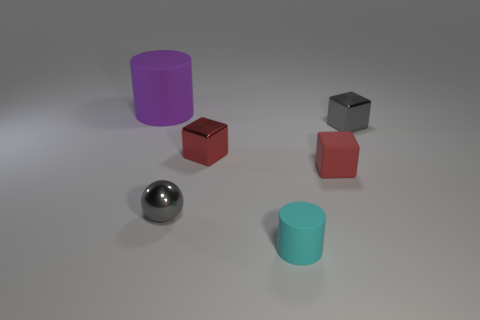Are the cyan cylinder and the tiny red thing that is to the left of the cyan thing made of the same material?
Make the answer very short. No. Do the cylinder that is left of the tiny gray shiny ball and the gray thing on the right side of the small sphere have the same material?
Your response must be concise. No. There is a gray thing that is the same shape as the red matte object; what is its size?
Your response must be concise. Small. How many small shiny cubes have the same color as the metal sphere?
Keep it short and to the point. 1. Are the purple cylinder and the small gray ball made of the same material?
Your response must be concise. No. What number of large purple objects are the same material as the cyan object?
Offer a very short reply. 1. There is a shiny cube on the right side of the cyan thing; is its color the same as the small shiny ball?
Keep it short and to the point. Yes. What number of tiny red matte things are the same shape as the purple object?
Your answer should be compact. 0. Are there an equal number of gray blocks in front of the red matte cube and large blue spheres?
Your answer should be compact. Yes. The cylinder that is the same size as the sphere is what color?
Provide a succinct answer. Cyan. 